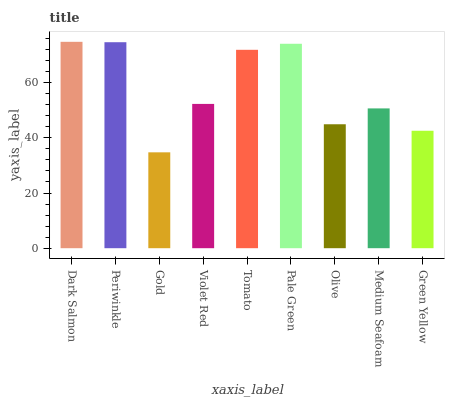Is Periwinkle the minimum?
Answer yes or no. No. Is Periwinkle the maximum?
Answer yes or no. No. Is Dark Salmon greater than Periwinkle?
Answer yes or no. Yes. Is Periwinkle less than Dark Salmon?
Answer yes or no. Yes. Is Periwinkle greater than Dark Salmon?
Answer yes or no. No. Is Dark Salmon less than Periwinkle?
Answer yes or no. No. Is Violet Red the high median?
Answer yes or no. Yes. Is Violet Red the low median?
Answer yes or no. Yes. Is Olive the high median?
Answer yes or no. No. Is Dark Salmon the low median?
Answer yes or no. No. 